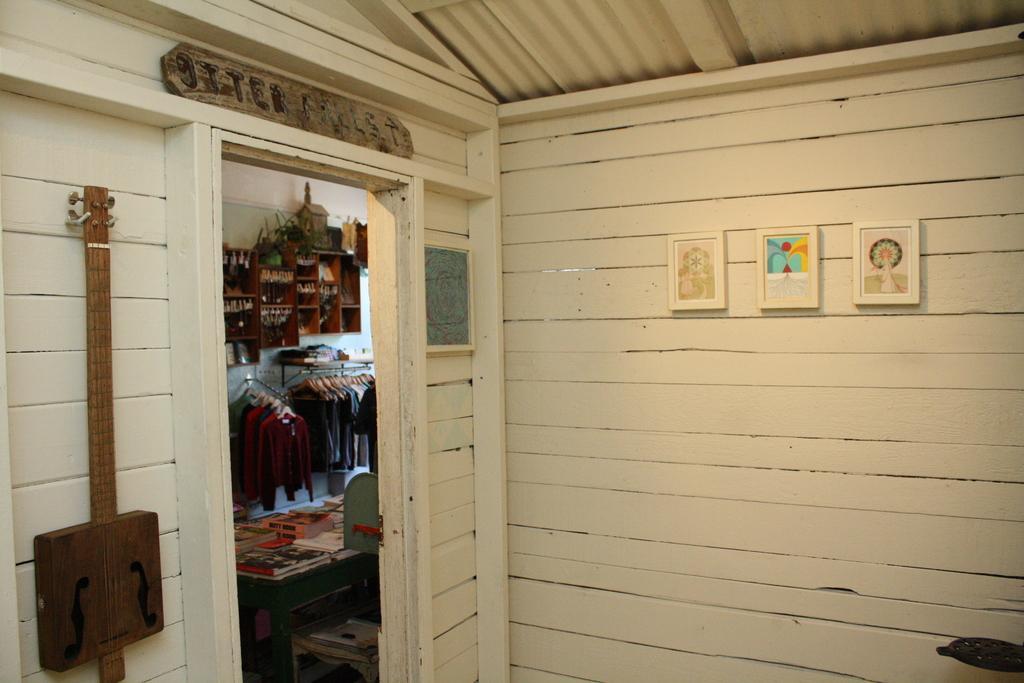How would you summarize this image in a sentence or two? In this image there are photo frames and a guitar on the wooden wall, on top of the entrance there is a name board, from the entrance in the other room we can see clothes on the hanger and there are some objects on the cupboards on the wall and there are books and some other objects on the table. 